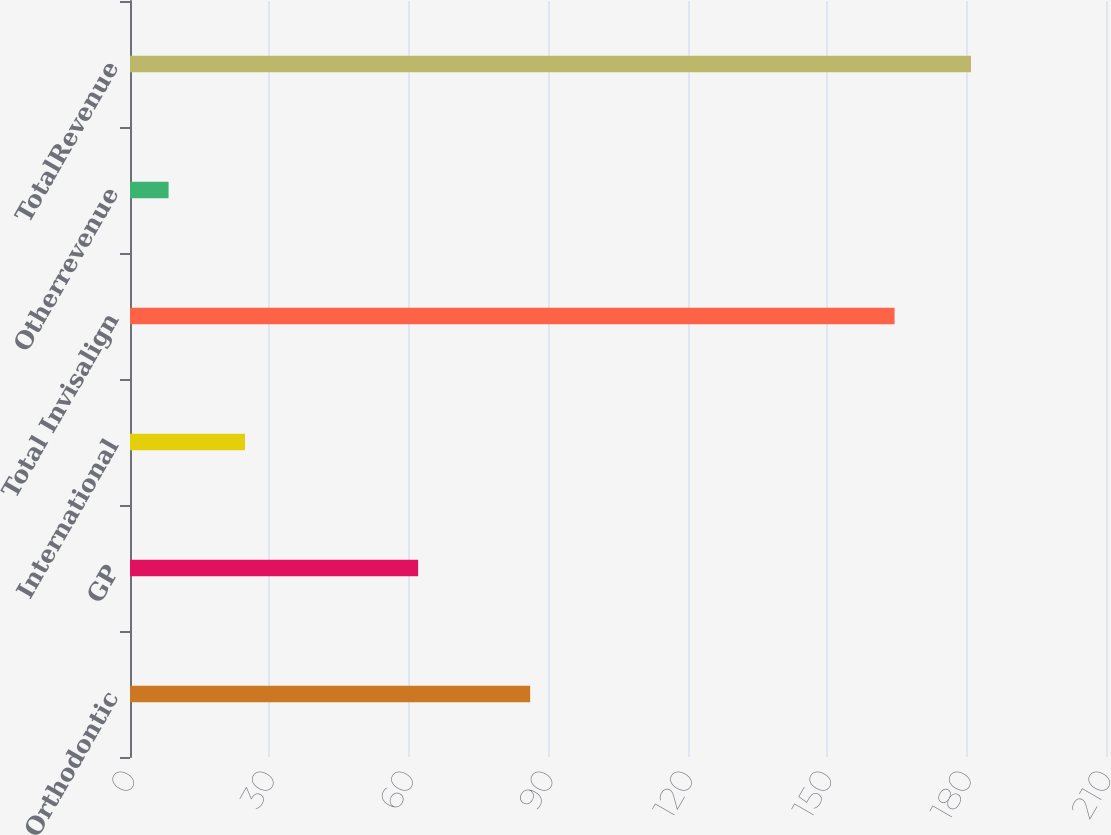Convert chart to OTSL. <chart><loc_0><loc_0><loc_500><loc_500><bar_chart><fcel>Orthodontic<fcel>GP<fcel>International<fcel>Total Invisalign<fcel>Otherrevenue<fcel>TotalRevenue<nl><fcel>86.1<fcel>62<fcel>24.75<fcel>164.5<fcel>8.3<fcel>180.95<nl></chart> 